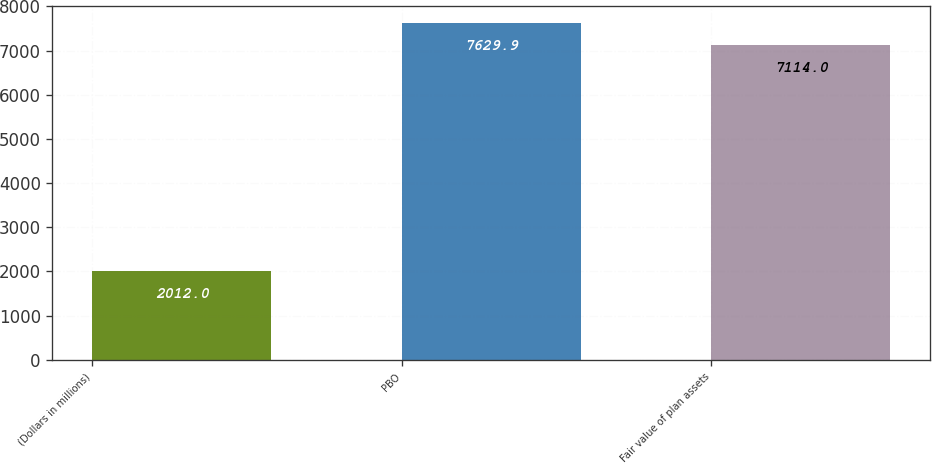Convert chart to OTSL. <chart><loc_0><loc_0><loc_500><loc_500><bar_chart><fcel>(Dollars in millions)<fcel>PBO<fcel>Fair value of plan assets<nl><fcel>2012<fcel>7629.9<fcel>7114<nl></chart> 